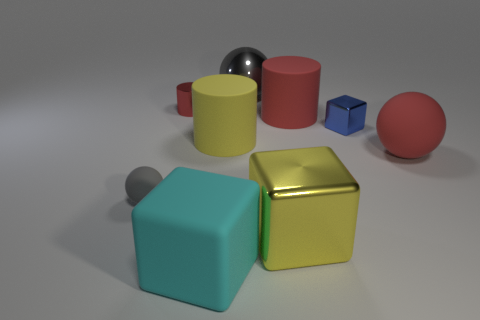What is the size of the matte thing that is on the right side of the gray metallic thing and in front of the blue object?
Make the answer very short. Large. What number of objects are either shiny things behind the red matte cylinder or large gray metal spheres?
Your response must be concise. 2. There is a tiny object that is both to the right of the tiny rubber ball and left of the tiny blue block; what shape is it?
Offer a terse response. Cylinder. There is a cube that is the same material as the tiny gray thing; what is its size?
Your answer should be compact. Large. How many objects are cylinders to the left of the cyan rubber cube or tiny metallic things that are to the left of the blue metallic object?
Offer a very short reply. 1. Do the gray thing that is on the left side of the cyan matte object and the blue metal thing have the same size?
Your answer should be very brief. Yes. There is a ball in front of the large red ball; what color is it?
Offer a terse response. Gray. There is a small object that is the same shape as the big yellow rubber thing; what is its color?
Give a very brief answer. Red. How many big metallic objects are in front of the metallic cube that is in front of the small metallic object that is in front of the tiny shiny cylinder?
Your response must be concise. 0. Are there fewer metal cylinders in front of the red shiny object than big cylinders?
Your answer should be very brief. Yes. 